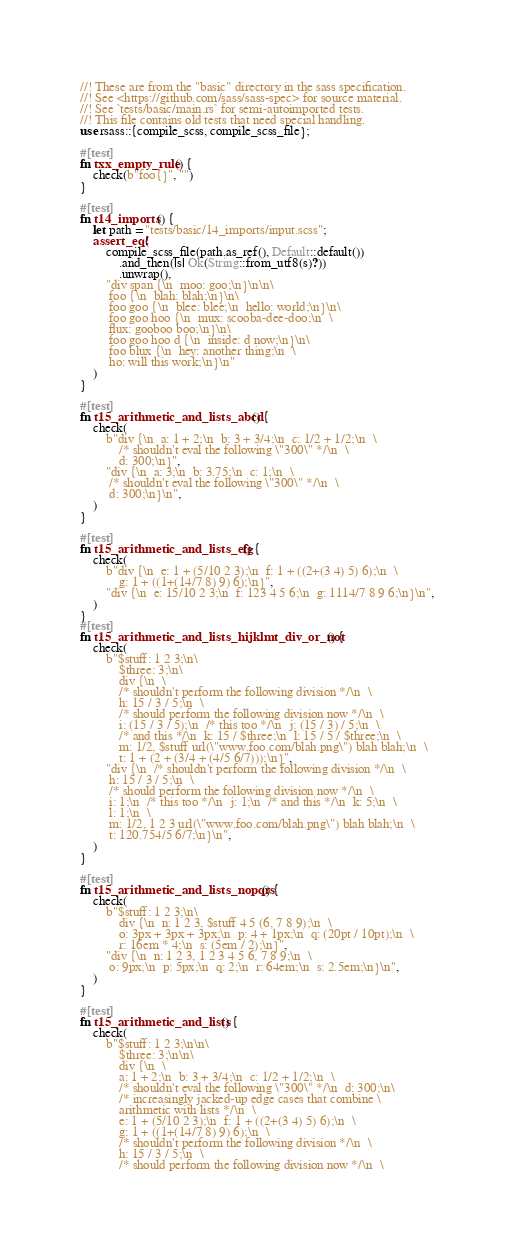<code> <loc_0><loc_0><loc_500><loc_500><_Rust_>//! These are from the "basic" directory in the sass specification.
//! See <https://github.com/sass/sass-spec> for source material.
//! See `tests/basic/main.rs` for semi-autoimported tests.
//! This file contains old tests that need special handling.
use rsass::{compile_scss, compile_scss_file};

#[test]
fn txx_empty_rule() {
    check(b"foo{}", "")
}

#[test]
fn t14_imports() {
    let path = "tests/basic/14_imports/input.scss";
    assert_eq!(
        compile_scss_file(path.as_ref(), Default::default())
            .and_then(|s| Ok(String::from_utf8(s)?))
            .unwrap(),
        "div span {\n  moo: goo;\n}\n\n\
         foo {\n  blah: blah;\n}\n\
         foo goo {\n  blee: blee;\n  hello: world;\n}\n\
         foo goo hoo {\n  mux: scooba-dee-doo;\n  \
         flux: gooboo boo;\n}\n\
         foo goo hoo d {\n  inside: d now;\n}\n\
         foo blux {\n  hey: another thing;\n  \
         ho: will this work;\n}\n"
    )
}

#[test]
fn t15_arithmetic_and_lists_abcd() {
    check(
        b"div {\n  a: 1 + 2;\n  b: 3 + 3/4;\n  c: 1/2 + 1/2;\n  \
            /* shouldn't eval the following \"300\" */\n  \
            d: 300;\n}",
        "div {\n  a: 3;\n  b: 3.75;\n  c: 1;\n  \
         /* shouldn't eval the following \"300\" */\n  \
         d: 300;\n}\n",
    )
}

#[test]
fn t15_arithmetic_and_lists_efg() {
    check(
        b"div {\n  e: 1 + (5/10 2 3);\n  f: 1 + ((2+(3 4) 5) 6);\n  \
            g: 1 + ((1+(14/7 8) 9) 6);\n}",
        "div {\n  e: 15/10 2 3;\n  f: 123 4 5 6;\n  g: 1114/7 8 9 6;\n}\n",
    )
}
#[test]
fn t15_arithmetic_and_lists_hijklmt_div_or_not() {
    check(
        b"$stuff: 1 2 3;\n\
            $three: 3;\n\
            div {\n  \
            /* shouldn't perform the following division */\n  \
            h: 15 / 3 / 5;\n  \
            /* should perform the following division now */\n  \
            i: (15 / 3 / 5);\n  /* this too */\n  j: (15 / 3) / 5;\n  \
            /* and this */\n  k: 15 / $three;\n  l: 15 / 5 / $three;\n  \
            m: 1/2, $stuff url(\"www.foo.com/blah.png\") blah blah;\n  \
            t: 1 + (2 + (3/4 + (4/5 6/7)));\n}",
        "div {\n  /* shouldn't perform the following division */\n  \
         h: 15 / 3 / 5;\n  \
         /* should perform the following division now */\n  \
         i: 1;\n  /* this too */\n  j: 1;\n  /* and this */\n  k: 5;\n  \
         l: 1;\n  \
         m: 1/2, 1 2 3 url(\"www.foo.com/blah.png\") blah blah;\n  \
         t: 120.754/5 6/7;\n}\n",
    )
}

#[test]
fn t15_arithmetic_and_lists_nopqrs() {
    check(
        b"$stuff: 1 2 3;\n\
            div {\n  n: 1 2 3, $stuff 4 5 (6, 7 8 9);\n  \
            o: 3px + 3px + 3px;\n  p: 4 + 1px;\n  q: (20pt / 10pt);\n  \
            r: 16em * 4;\n  s: (5em / 2);\n}",
        "div {\n  n: 1 2 3, 1 2 3 4 5 6, 7 8 9;\n  \
         o: 9px;\n  p: 5px;\n  q: 2;\n  r: 64em;\n  s: 2.5em;\n}\n",
    )
}

#[test]
fn t15_arithmetic_and_lists() {
    check(
        b"$stuff: 1 2 3;\n\n\
            $three: 3;\n\n\
            div {\n  \
            a: 1 + 2;\n  b: 3 + 3/4;\n  c: 1/2 + 1/2;\n  \
            /* shouldn't eval the following \"300\" */\n  d: 300;\n\
            /* increasingly jacked-up edge cases that combine \
            arithmetic with lists */\n  \
            e: 1 + (5/10 2 3);\n  f: 1 + ((2+(3 4) 5) 6);\n  \
            g: 1 + ((1+(14/7 8) 9) 6);\n  \
            /* shouldn't perform the following division */\n  \
            h: 15 / 3 / 5;\n  \
            /* should perform the following division now */\n  \</code> 